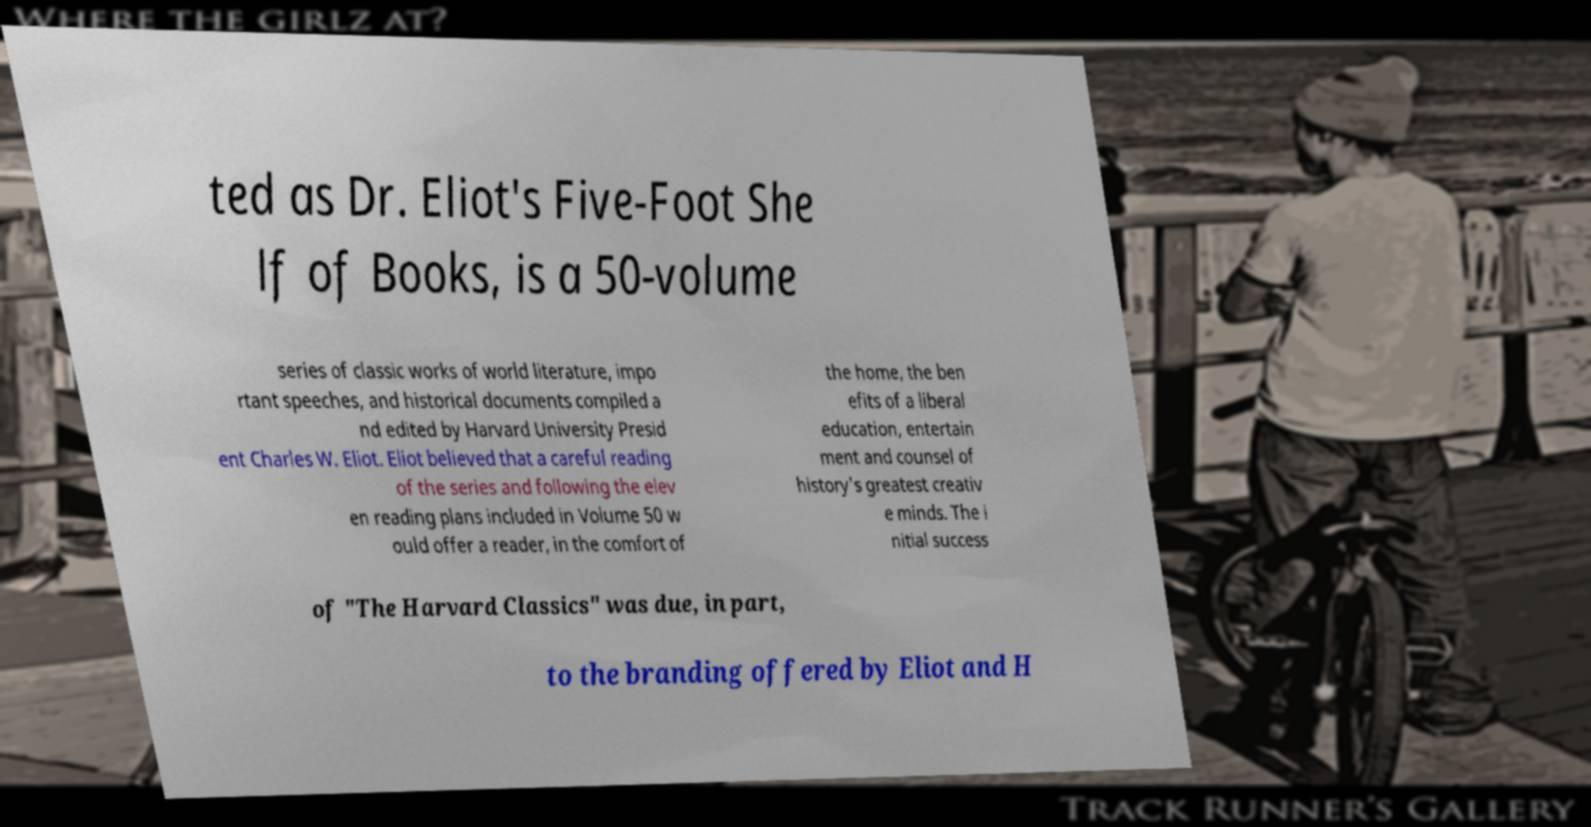Please identify and transcribe the text found in this image. ted as Dr. Eliot's Five-Foot She lf of Books, is a 50-volume series of classic works of world literature, impo rtant speeches, and historical documents compiled a nd edited by Harvard University Presid ent Charles W. Eliot. Eliot believed that a careful reading of the series and following the elev en reading plans included in Volume 50 w ould offer a reader, in the comfort of the home, the ben efits of a liberal education, entertain ment and counsel of history's greatest creativ e minds. The i nitial success of "The Harvard Classics" was due, in part, to the branding offered by Eliot and H 